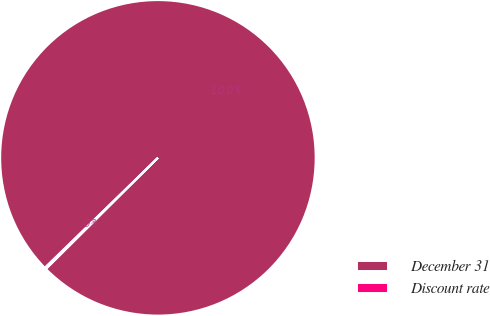<chart> <loc_0><loc_0><loc_500><loc_500><pie_chart><fcel>December 31<fcel>Discount rate<nl><fcel>99.83%<fcel>0.17%<nl></chart> 